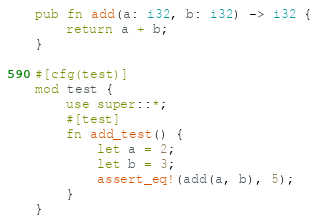Convert code to text. <code><loc_0><loc_0><loc_500><loc_500><_Rust_>pub fn add(a: i32, b: i32) -> i32 {
    return a + b;
}

#[cfg(test)]
mod test {
    use super::*;
    #[test]
    fn add_test() {
        let a = 2;
        let b = 3;
        assert_eq!(add(a, b), 5);
    }
}
</code> 